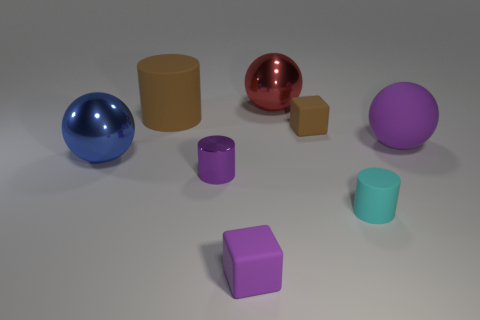What is the color of the other cylinder that is the same size as the metal cylinder?
Ensure brevity in your answer.  Cyan. There is a big red thing; what shape is it?
Make the answer very short. Sphere. Are there more tiny purple cylinders behind the blue ball than small purple rubber things that are to the right of the tiny cyan object?
Give a very brief answer. No. What number of other things are there of the same size as the purple rubber sphere?
Make the answer very short. 3. There is a cylinder that is both in front of the large purple thing and left of the small cyan thing; what is its material?
Give a very brief answer. Metal. There is a purple thing that is the same shape as the tiny brown object; what material is it?
Make the answer very short. Rubber. What is the material of the big cylinder?
Your answer should be very brief. Rubber. The big sphere that is left of the small matte cube that is in front of the purple matte object to the right of the tiny purple matte object is made of what material?
Give a very brief answer. Metal. Is there any other thing that has the same material as the blue object?
Your response must be concise. Yes. Do the purple cylinder and the matte cube behind the large blue object have the same size?
Provide a succinct answer. Yes. 